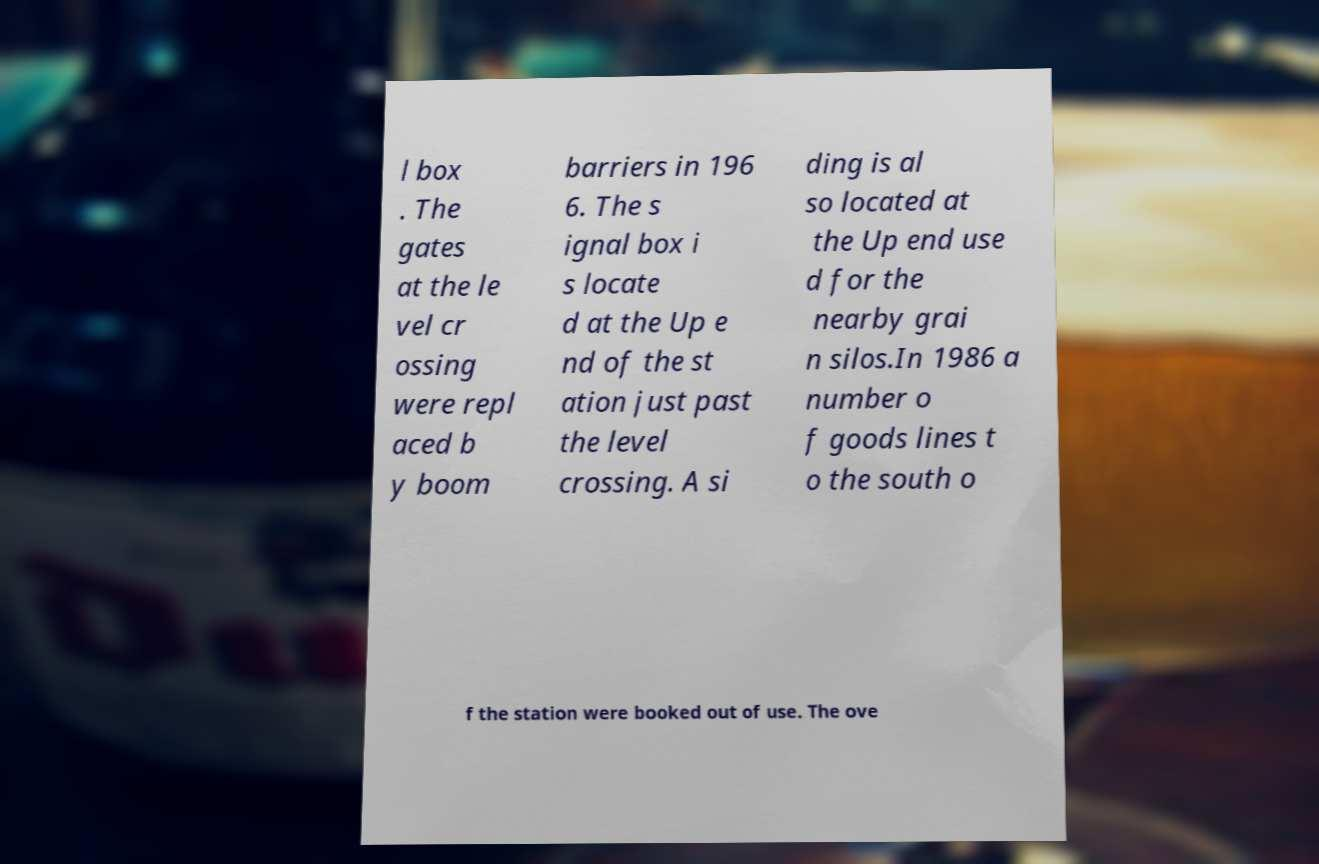What messages or text are displayed in this image? I need them in a readable, typed format. l box . The gates at the le vel cr ossing were repl aced b y boom barriers in 196 6. The s ignal box i s locate d at the Up e nd of the st ation just past the level crossing. A si ding is al so located at the Up end use d for the nearby grai n silos.In 1986 a number o f goods lines t o the south o f the station were booked out of use. The ove 